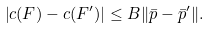<formula> <loc_0><loc_0><loc_500><loc_500>\left | c ( F ) - c ( F ^ { \prime } ) \right | \leq B \| \bar { p } - \bar { p } ^ { \prime } \| .</formula> 